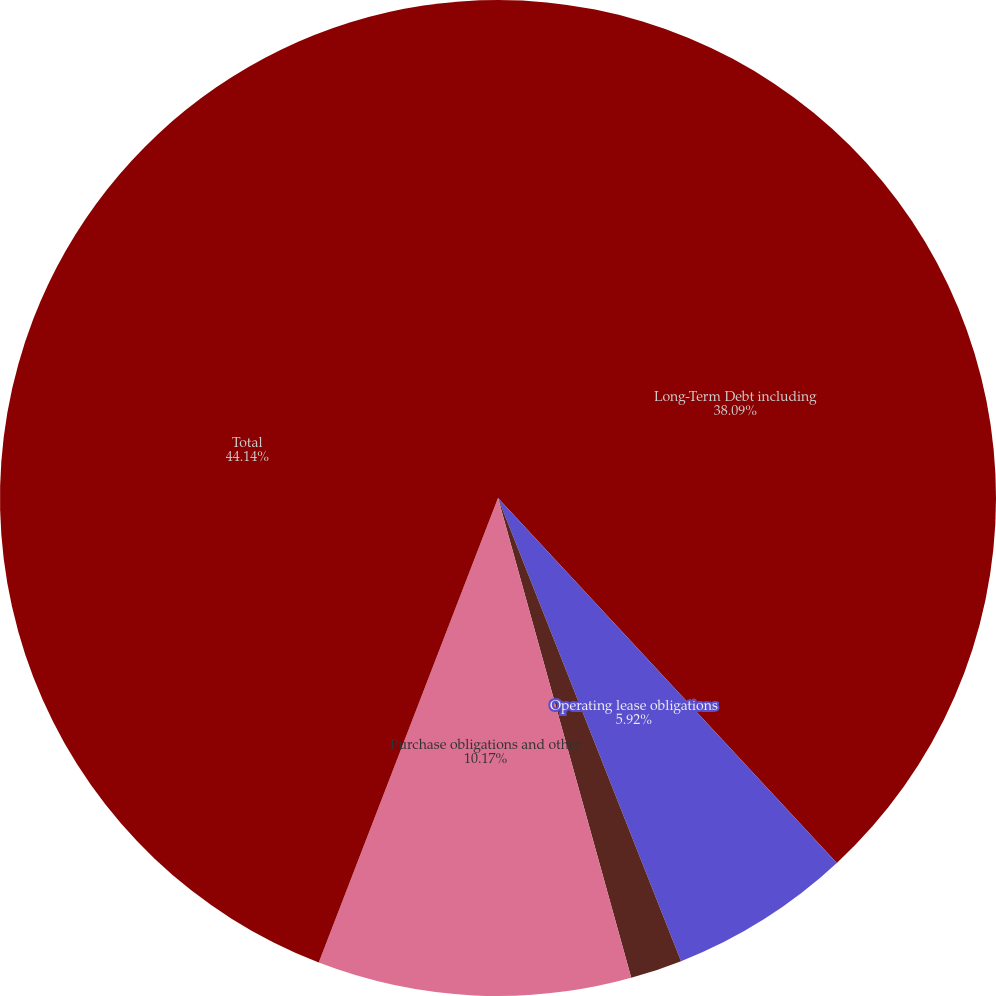Convert chart. <chart><loc_0><loc_0><loc_500><loc_500><pie_chart><fcel>Long-Term Debt including<fcel>Operating lease obligations<fcel>Capital lease obligations (3)<fcel>Purchase obligations and other<fcel>Total<nl><fcel>38.09%<fcel>5.92%<fcel>1.68%<fcel>10.17%<fcel>44.14%<nl></chart> 